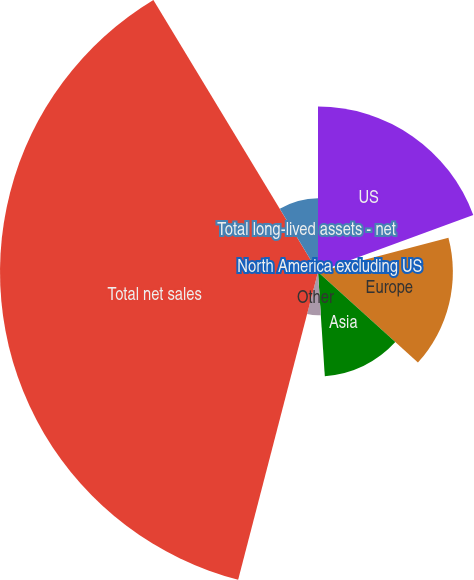<chart> <loc_0><loc_0><loc_500><loc_500><pie_chart><fcel>US<fcel>North America excluding US<fcel>Europe<fcel>Asia<fcel>Other<fcel>Total net sales<fcel>Total long-lived assets - net<nl><fcel>19.4%<fcel>1.5%<fcel>15.82%<fcel>12.24%<fcel>5.08%<fcel>37.3%<fcel>8.66%<nl></chart> 